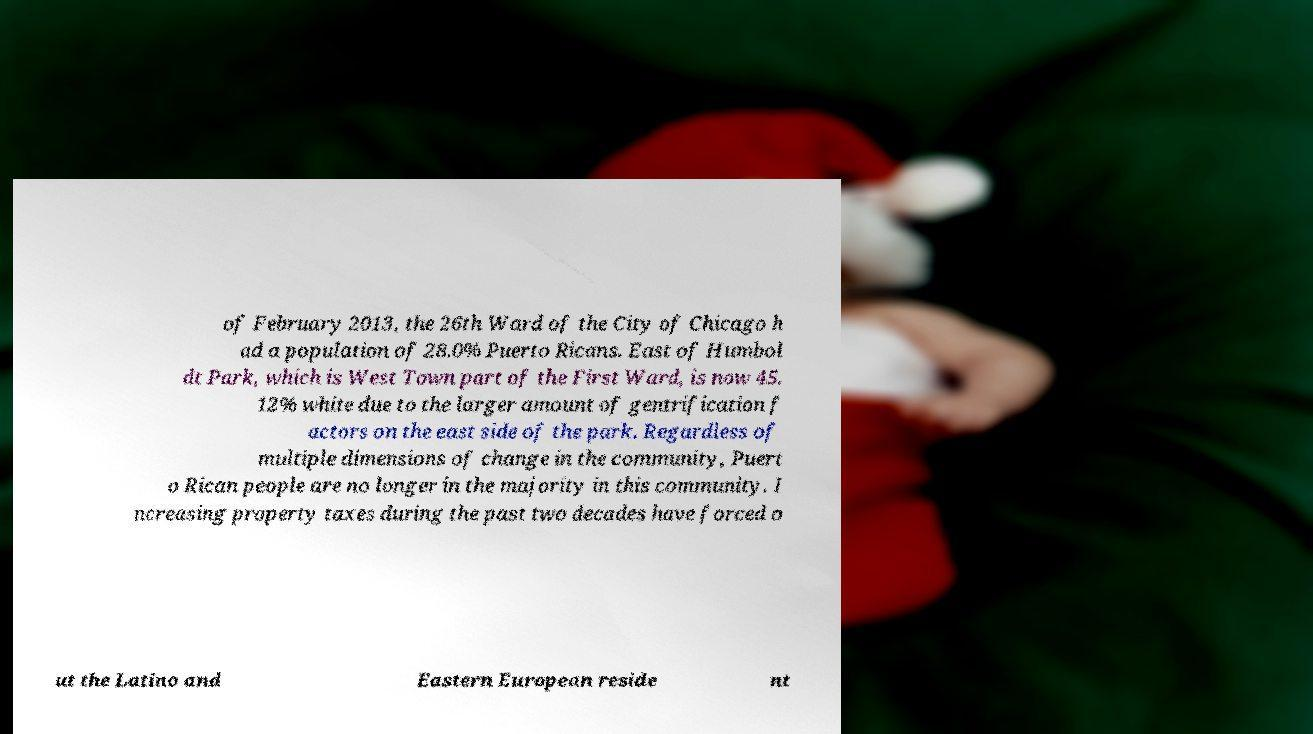Could you assist in decoding the text presented in this image and type it out clearly? of February 2013, the 26th Ward of the City of Chicago h ad a population of 28.0% Puerto Ricans. East of Humbol dt Park, which is West Town part of the First Ward, is now 45. 12% white due to the larger amount of gentrification f actors on the east side of the park. Regardless of multiple dimensions of change in the community, Puert o Rican people are no longer in the majority in this community. I ncreasing property taxes during the past two decades have forced o ut the Latino and Eastern European reside nt 